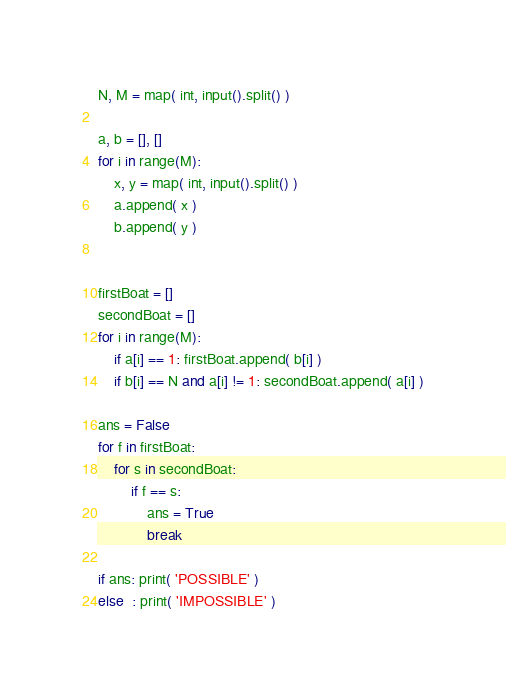Convert code to text. <code><loc_0><loc_0><loc_500><loc_500><_Python_>N, M = map( int, input().split() )

a, b = [], []
for i in range(M):
    x, y = map( int, input().split() )
    a.append( x )
    b.append( y )


firstBoat = []
secondBoat = []
for i in range(M):
    if a[i] == 1: firstBoat.append( b[i] )
    if b[i] == N and a[i] != 1: secondBoat.append( a[i] )

ans = False
for f in firstBoat:
    for s in secondBoat:
        if f == s:
            ans = True
            break

if ans: print( 'POSSIBLE' )
else  : print( 'IMPOSSIBLE' )

</code> 